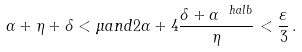<formula> <loc_0><loc_0><loc_500><loc_500>\alpha + \eta + \delta < \mu a n d 2 \alpha + 4 \frac { \delta + \alpha ^ { \ h a l b } } { \eta } < \frac { \varepsilon } { 3 } \, .</formula> 